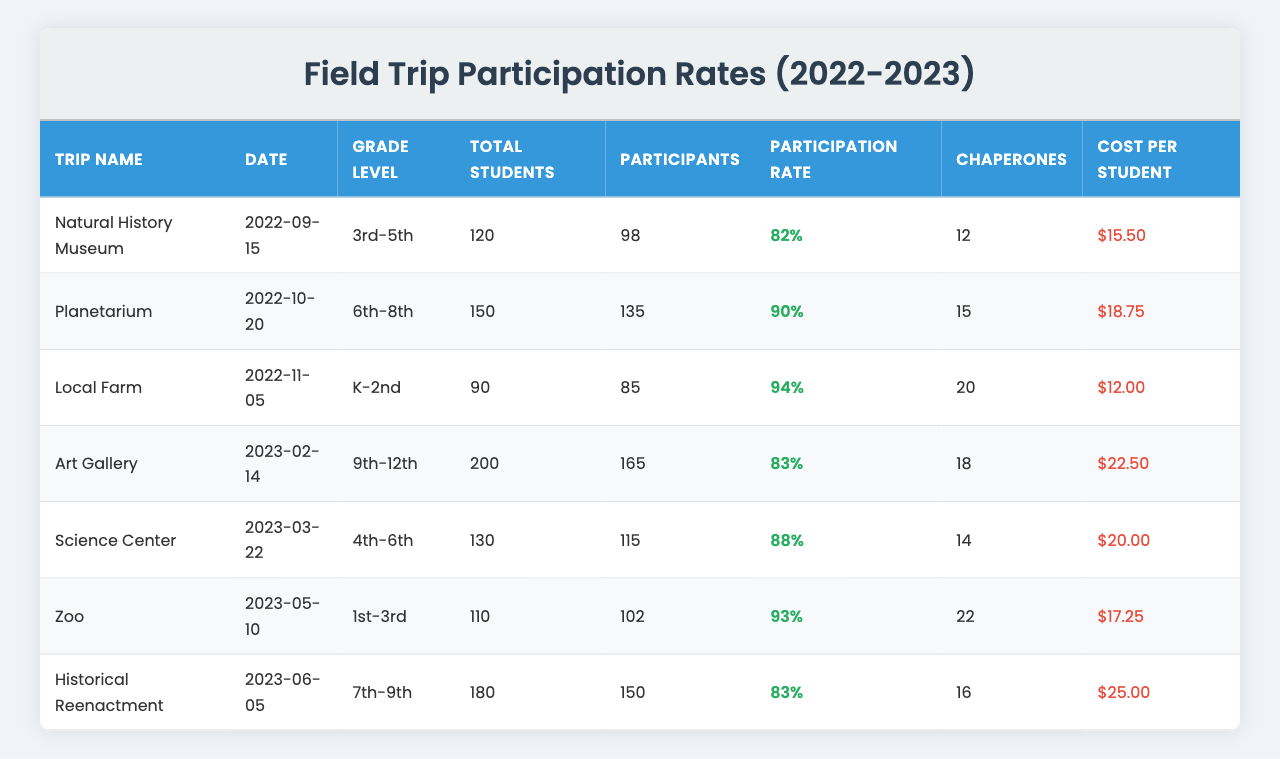What was the participation rate for the Natural History Museum trip? The participation rate for the Natural History Museum trip is listed in the table as 0.82, which corresponds to 82%.
Answer: 82% How many chaperones were present for the Zoo trip? According to the table, there were 22 chaperones for the Zoo trip.
Answer: 22 Which trip had the highest participation rate? To find the highest participation rate, we can look at the "Participation Rate" column. The Local Farm trip has the highest rate at 94%.
Answer: Local Farm What was the total number of participants for the Science Center field trip? The table indicates that there were 115 participants for the Science Center field trip.
Answer: 115 What is the average participation rate for all trips listed? The average participation rate is calculated by summing all participation rates (0.82 + 0.90 + 0.94 + 0.83 + 0.88 + 0.93 + 0.83 = 0.82 + 0.90 + 0.94 + 0.83 + 0.88 + 0.93 + 0.83 = 6.13), and dividing by the number of trips (7). Therefore, the average rate is 6.13 / 7 ≈ 0.8757 or 87.57%.
Answer: Approximately 87.57% Was the cost per student for the Historical Reenactment trip higher than the cost for the Planetarium trip? The cost per student for the Historical Reenactment trip is $25.00, while the cost for the Planetarium trip is $18.75. Since $25.00 is greater than $18.75, the statement is true.
Answer: Yes How many total students were involved in all the trips combined? By adding the total students from all trips: 120 + 150 + 90 + 200 + 130 + 110 + 180 = 1080. Thus, the total number of students across all trips is 1080.
Answer: 1080 Which trip had the least number of participants, and what was the participation rate for that trip? The Local Farm trip had 85 participants, which is the least when compared to other trips. The participation rate for that trip was 94%.
Answer: Local Farm, 94% Was the participation rate for the 1st-3rd grade trip higher than that for the 6th-8th grade trip? The participation rate for the Zoo trip (1st-3rd grade) is 93%, while the Planetarium trip (6th-8th grade) has a participation rate of 90%. Therefore, the participation rate for the Zoo trip is higher.
Answer: Yes What is the total cost for all students attending the Art Gallery trip? The cost per student for the Art Gallery trip is $22.50 with a total of 165 participants. Therefore, the total cost is calculated as 165 * 22.50 = $3,712.50.
Answer: $3,712.50 What was the date of the Historical Reenactment trip? The table shows that the Historical Reenactment trip took place on June 5, 2023.
Answer: June 5, 2023 